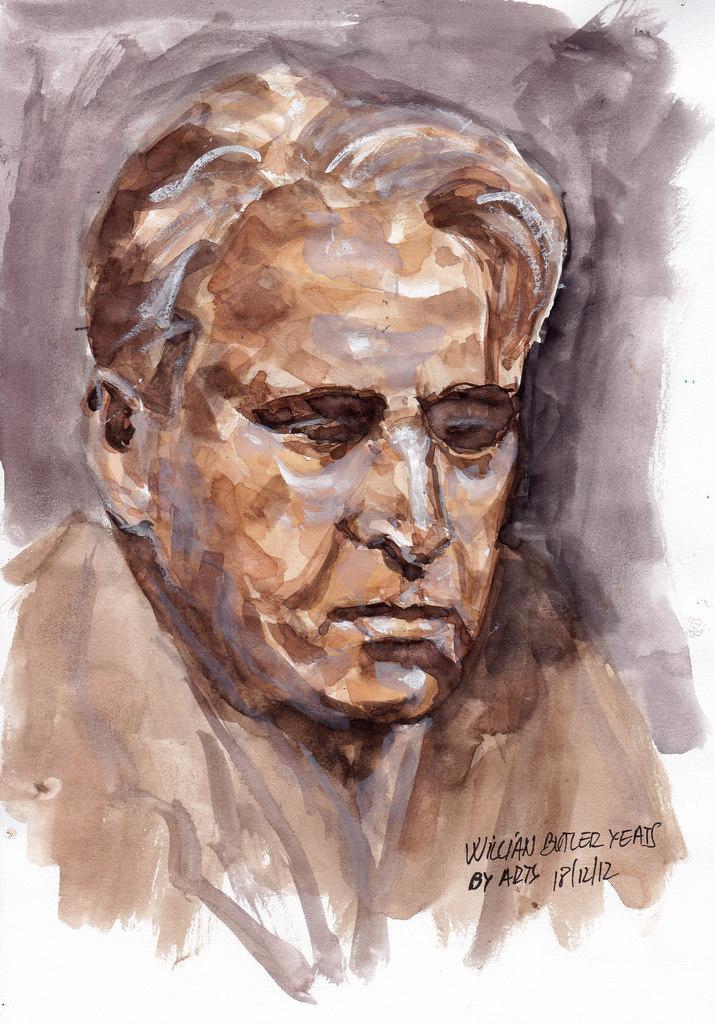Describe this image in one or two sentences. In this image, we can see a painting. Here we can see a person. On the right side of the image, we can see some text. 